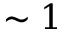<formula> <loc_0><loc_0><loc_500><loc_500>\sim 1</formula> 